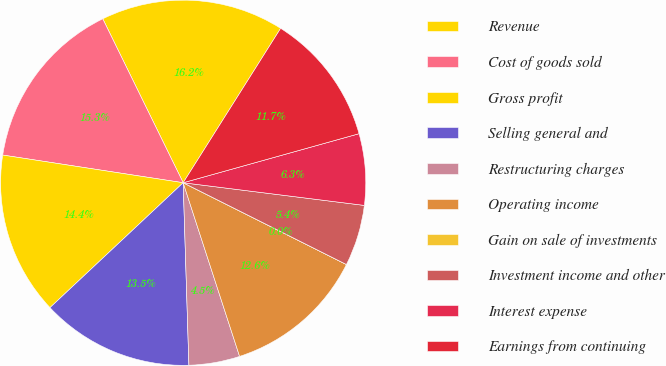Convert chart to OTSL. <chart><loc_0><loc_0><loc_500><loc_500><pie_chart><fcel>Revenue<fcel>Cost of goods sold<fcel>Gross profit<fcel>Selling general and<fcel>Restructuring charges<fcel>Operating income<fcel>Gain on sale of investments<fcel>Investment income and other<fcel>Interest expense<fcel>Earnings from continuing<nl><fcel>16.22%<fcel>15.32%<fcel>14.41%<fcel>13.51%<fcel>4.5%<fcel>12.61%<fcel>0.0%<fcel>5.41%<fcel>6.31%<fcel>11.71%<nl></chart> 